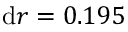<formula> <loc_0><loc_0><loc_500><loc_500>d r = 0 . 1 9 5</formula> 